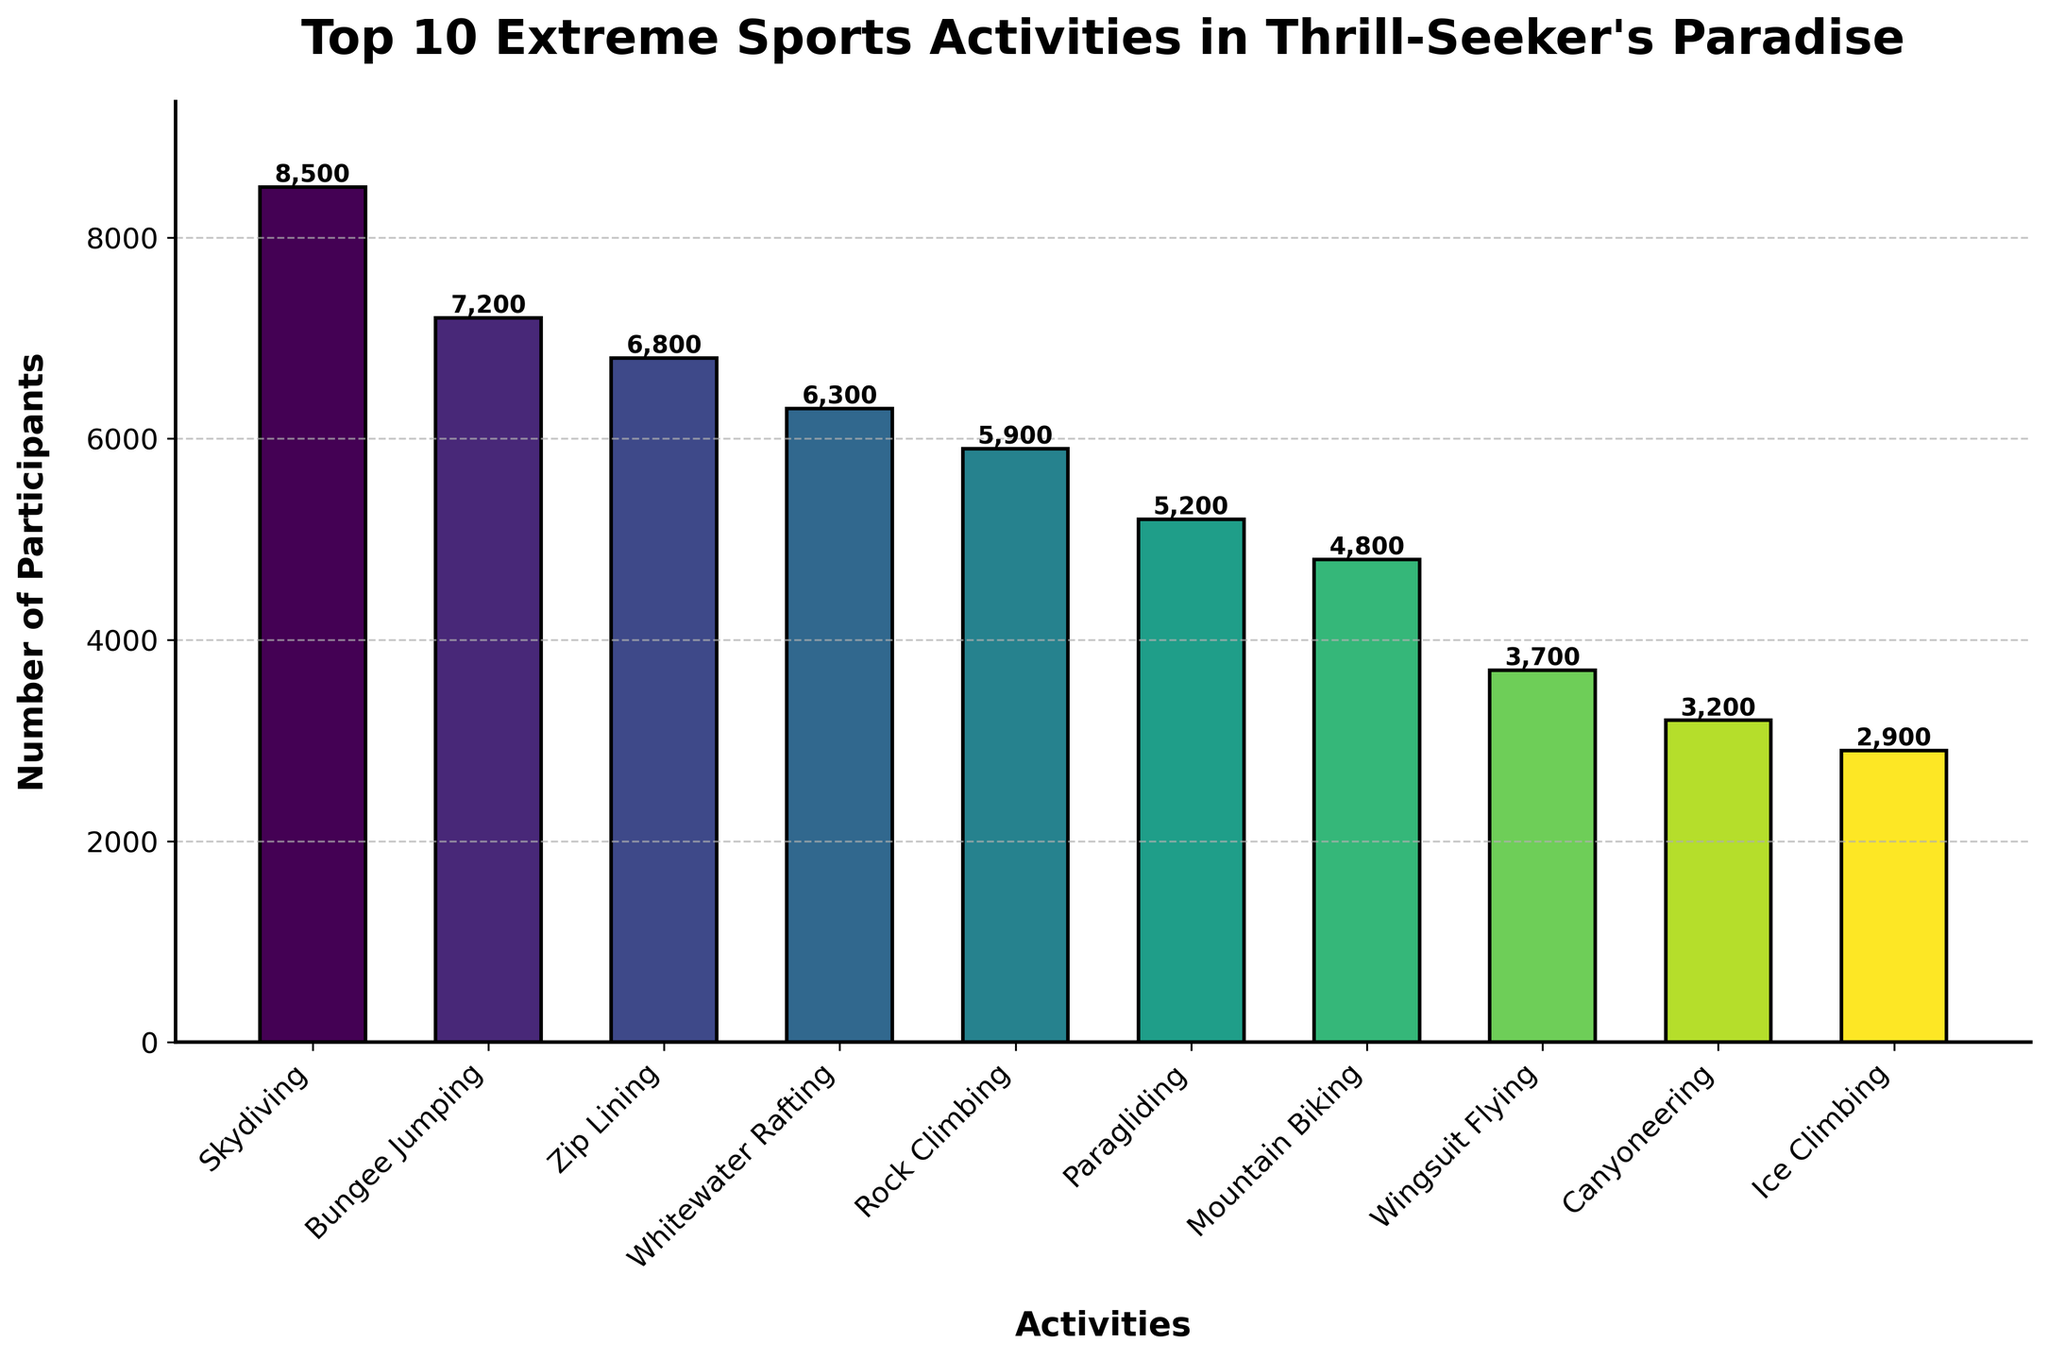What is the most popular extreme sports activity in the city? The bar representing Skydiving reaches the highest point on the y-axis, indicating it has the greatest number of participants.
Answer: Skydiving Which extreme sports activity has the least number of participants? The bar for Ice Climbing is the shortest among all activities, indicating it has the lowest number of participants.
Answer: Ice Climbing How many participants are there in Rock Climbing and Ice Climbing combined? The number of participants in Rock Climbing is 5900 and in Ice Climbing is 2900. Adding these values together gives 5900 + 2900 = 8800.
Answer: 8800 What is the difference in participants between Skydiving and Bungee Jumping? The number of participants for Skydiving is 8500 and for Bungee Jumping is 7200. The difference is 8500 - 7200 = 1300.
Answer: 1300 Which activity has more participants, Paragliding or Mountain Biking? Comparing the heights of the bars, Paragliding has 5200 participants, while Mountain Biking has 4800. Since 5200 is greater than 4800, Paragliding has more participants.
Answer: Paragliding What is the average number of participants for the top 3 most popular activities? The top 3 activities by participants are Skydiving (8500), Bungee Jumping (7200), and Zip Lining (6800). Their average is (8500 + 7200 + 6800) / 3 = 7500.
Answer: 7500 Which activity's bar color is the lightest shade? The colors transition from dark to light. The lightest shade is typically given to the last activity, which is Ice Climbing.
Answer: Ice Climbing Is the number of participants for Whitewater Rafting greater than that for Zip Lining? Whitewater Rafting has 6300 participants, and Zip Lining has 6800. Since 6300 is not greater than 6800, the answer is no.
Answer: No How does the number of participants in Wingsuit Flying compare to Paragliding? The bar for Wingsuit Flying shows 3700 participants and Paragliding shows 5200 participants. Comparing 3700 to 5200, Wingsuit Flying has fewer participants than Paragliding.
Answer: Fewer What is the total number of participants across all activities? Sum the participants: 8500 (Skydiving) + 7200 (Bungee Jumping) + 6800 (Zip Lining) + 6300 (Whitewater Rafting) + 5900 (Rock Climbing) + 5200 (Paragliding) + 4800 (Mountain Biking) + 3700 (Wingsuit Flying) + 3200 (Canyoneering) + 2900 (Ice Climbing) = 54500.
Answer: 54500 